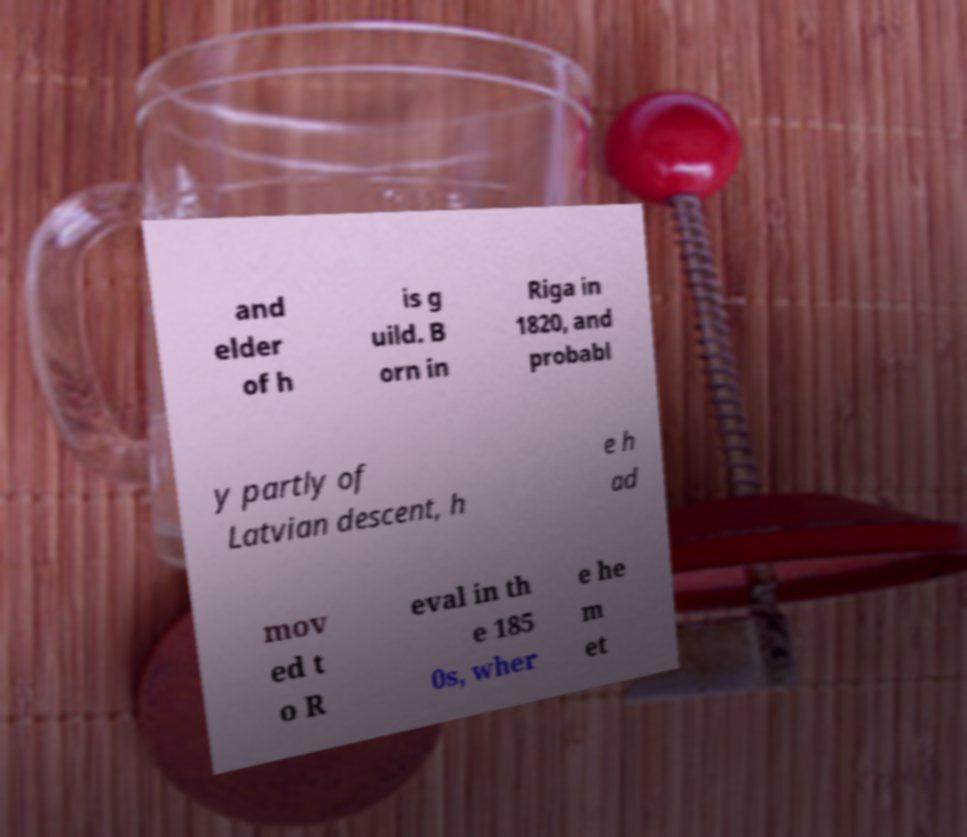Could you extract and type out the text from this image? and elder of h is g uild. B orn in Riga in 1820, and probabl y partly of Latvian descent, h e h ad mov ed t o R eval in th e 185 0s, wher e he m et 